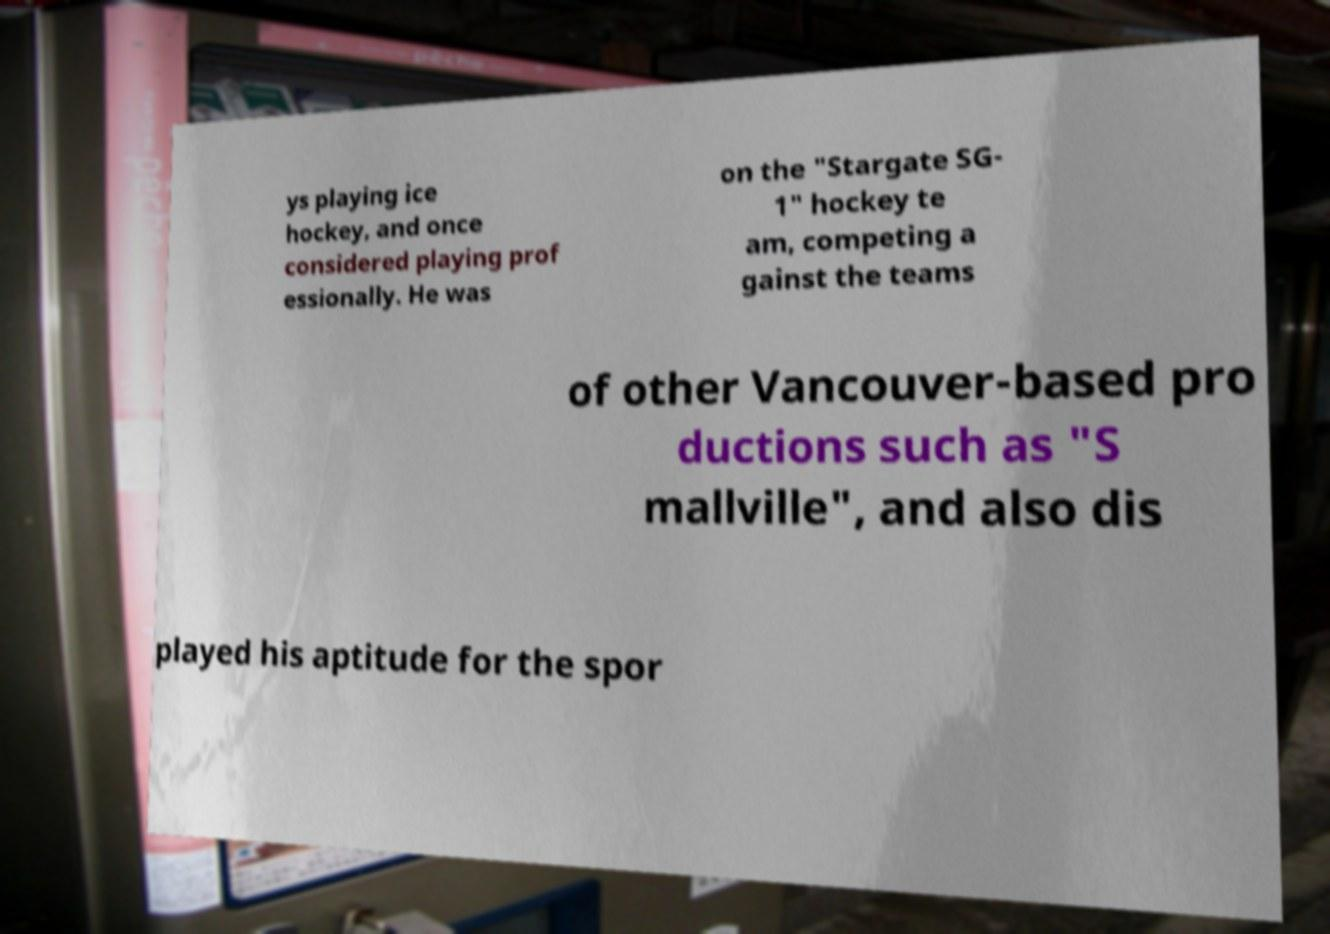Please identify and transcribe the text found in this image. ys playing ice hockey, and once considered playing prof essionally. He was on the "Stargate SG- 1" hockey te am, competing a gainst the teams of other Vancouver-based pro ductions such as "S mallville", and also dis played his aptitude for the spor 